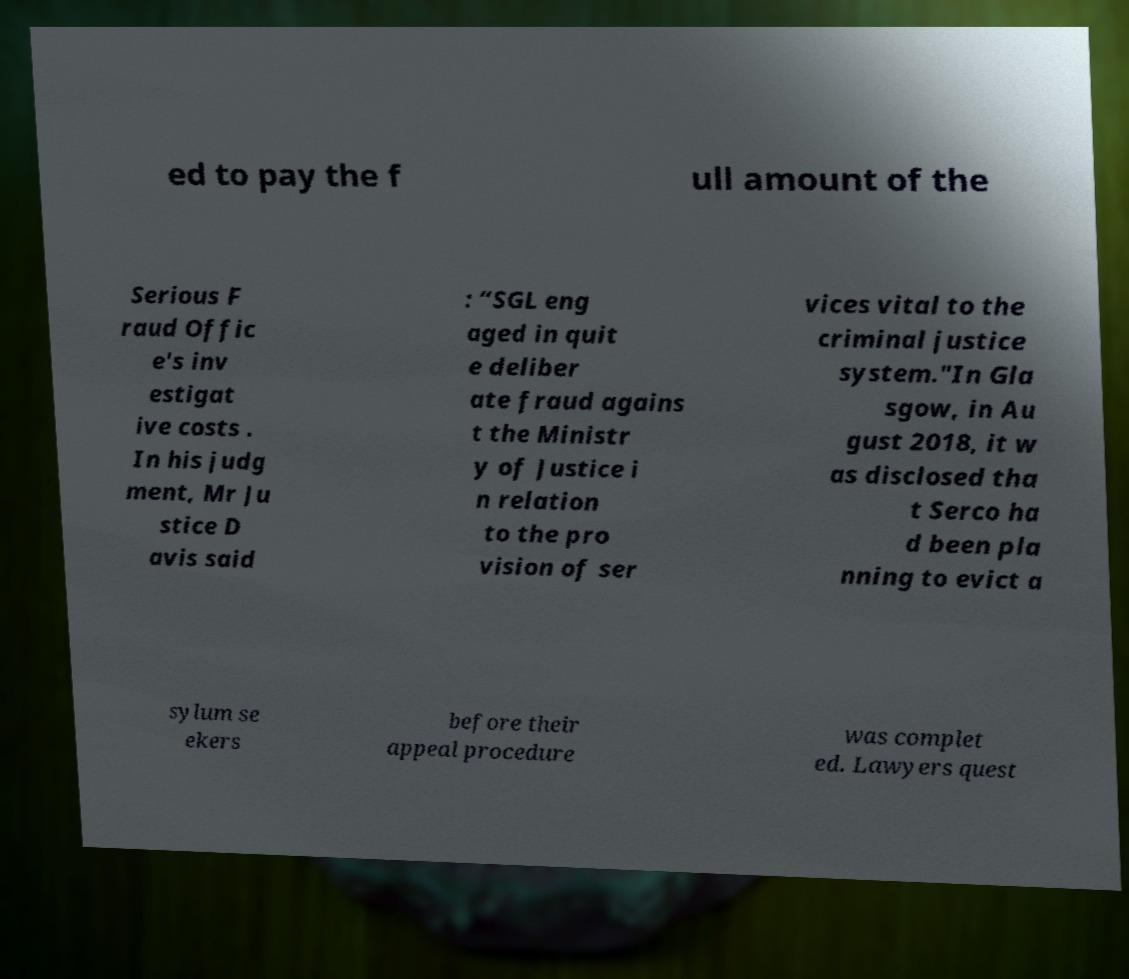What messages or text are displayed in this image? I need them in a readable, typed format. ed to pay the f ull amount of the Serious F raud Offic e's inv estigat ive costs . In his judg ment, Mr Ju stice D avis said : “SGL eng aged in quit e deliber ate fraud agains t the Ministr y of Justice i n relation to the pro vision of ser vices vital to the criminal justice system."In Gla sgow, in Au gust 2018, it w as disclosed tha t Serco ha d been pla nning to evict a sylum se ekers before their appeal procedure was complet ed. Lawyers quest 